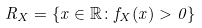Convert formula to latex. <formula><loc_0><loc_0><loc_500><loc_500>R _ { X } = \{ x \in \mathbb { R } \colon f _ { X } ( x ) > 0 \}</formula> 